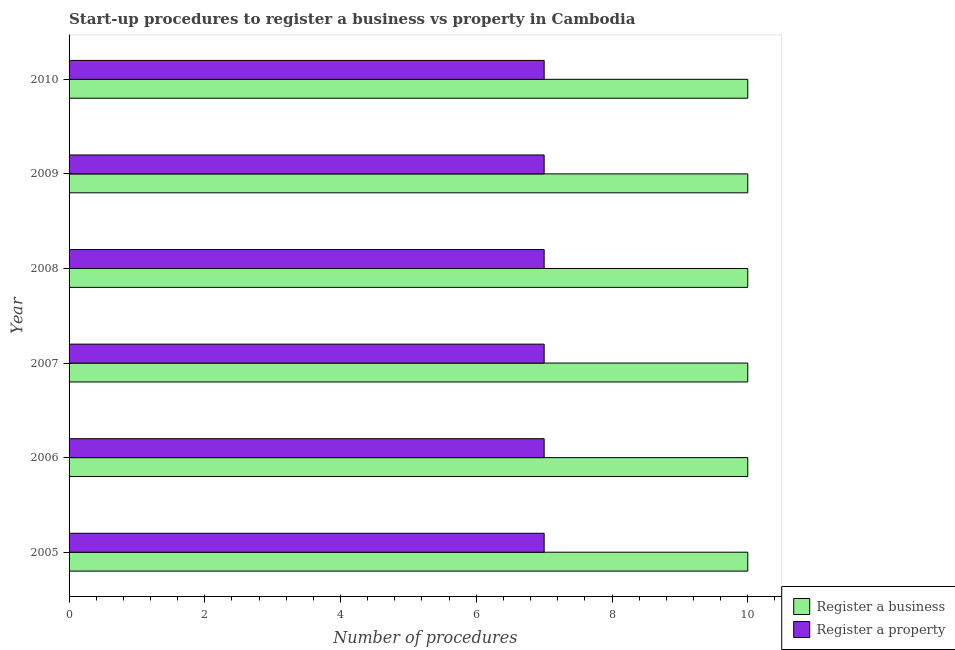How many different coloured bars are there?
Give a very brief answer. 2. How many groups of bars are there?
Offer a terse response. 6. How many bars are there on the 5th tick from the top?
Ensure brevity in your answer.  2. In how many cases, is the number of bars for a given year not equal to the number of legend labels?
Provide a succinct answer. 0. What is the number of procedures to register a property in 2009?
Make the answer very short. 7. Across all years, what is the maximum number of procedures to register a business?
Keep it short and to the point. 10. Across all years, what is the minimum number of procedures to register a business?
Offer a terse response. 10. In which year was the number of procedures to register a business minimum?
Offer a very short reply. 2005. What is the total number of procedures to register a property in the graph?
Offer a very short reply. 42. What is the difference between the number of procedures to register a property in 2007 and the number of procedures to register a business in 2006?
Make the answer very short. -3. What is the average number of procedures to register a business per year?
Your response must be concise. 10. In the year 2005, what is the difference between the number of procedures to register a property and number of procedures to register a business?
Make the answer very short. -3. In how many years, is the number of procedures to register a business greater than 4.8 ?
Your answer should be very brief. 6. What is the ratio of the number of procedures to register a business in 2007 to that in 2010?
Keep it short and to the point. 1. Is the difference between the number of procedures to register a business in 2007 and 2008 greater than the difference between the number of procedures to register a property in 2007 and 2008?
Offer a very short reply. No. What is the difference between the highest and the second highest number of procedures to register a business?
Ensure brevity in your answer.  0. What does the 2nd bar from the top in 2005 represents?
Your answer should be compact. Register a business. What does the 2nd bar from the bottom in 2005 represents?
Offer a very short reply. Register a property. How many bars are there?
Provide a succinct answer. 12. What is the difference between two consecutive major ticks on the X-axis?
Make the answer very short. 2. Are the values on the major ticks of X-axis written in scientific E-notation?
Your answer should be compact. No. Does the graph contain any zero values?
Your answer should be very brief. No. Does the graph contain grids?
Your answer should be very brief. No. Where does the legend appear in the graph?
Keep it short and to the point. Bottom right. What is the title of the graph?
Give a very brief answer. Start-up procedures to register a business vs property in Cambodia. What is the label or title of the X-axis?
Ensure brevity in your answer.  Number of procedures. What is the Number of procedures in Register a business in 2005?
Ensure brevity in your answer.  10. What is the Number of procedures in Register a property in 2005?
Make the answer very short. 7. What is the Number of procedures of Register a business in 2006?
Provide a short and direct response. 10. What is the Number of procedures in Register a business in 2008?
Keep it short and to the point. 10. What is the Number of procedures in Register a business in 2009?
Offer a terse response. 10. What is the Number of procedures of Register a property in 2010?
Provide a short and direct response. 7. Across all years, what is the maximum Number of procedures of Register a property?
Your response must be concise. 7. What is the total Number of procedures in Register a property in the graph?
Keep it short and to the point. 42. What is the difference between the Number of procedures in Register a property in 2005 and that in 2008?
Make the answer very short. 0. What is the difference between the Number of procedures in Register a business in 2005 and that in 2009?
Offer a very short reply. 0. What is the difference between the Number of procedures of Register a business in 2005 and that in 2010?
Keep it short and to the point. 0. What is the difference between the Number of procedures in Register a business in 2006 and that in 2007?
Provide a short and direct response. 0. What is the difference between the Number of procedures in Register a property in 2006 and that in 2008?
Make the answer very short. 0. What is the difference between the Number of procedures of Register a property in 2006 and that in 2009?
Offer a terse response. 0. What is the difference between the Number of procedures in Register a business in 2006 and that in 2010?
Keep it short and to the point. 0. What is the difference between the Number of procedures of Register a property in 2006 and that in 2010?
Offer a terse response. 0. What is the difference between the Number of procedures in Register a business in 2007 and that in 2008?
Your response must be concise. 0. What is the difference between the Number of procedures of Register a business in 2007 and that in 2009?
Your response must be concise. 0. What is the difference between the Number of procedures in Register a property in 2007 and that in 2009?
Keep it short and to the point. 0. What is the difference between the Number of procedures in Register a property in 2007 and that in 2010?
Provide a succinct answer. 0. What is the difference between the Number of procedures of Register a business in 2008 and that in 2009?
Offer a very short reply. 0. What is the difference between the Number of procedures in Register a business in 2008 and that in 2010?
Keep it short and to the point. 0. What is the difference between the Number of procedures in Register a property in 2008 and that in 2010?
Offer a terse response. 0. What is the difference between the Number of procedures of Register a business in 2009 and that in 2010?
Keep it short and to the point. 0. What is the difference between the Number of procedures in Register a property in 2009 and that in 2010?
Your answer should be compact. 0. What is the difference between the Number of procedures in Register a business in 2005 and the Number of procedures in Register a property in 2010?
Your answer should be compact. 3. What is the difference between the Number of procedures in Register a business in 2006 and the Number of procedures in Register a property in 2007?
Your answer should be compact. 3. What is the difference between the Number of procedures in Register a business in 2006 and the Number of procedures in Register a property in 2009?
Provide a short and direct response. 3. What is the difference between the Number of procedures of Register a business in 2007 and the Number of procedures of Register a property in 2009?
Your answer should be very brief. 3. What is the difference between the Number of procedures in Register a business in 2007 and the Number of procedures in Register a property in 2010?
Ensure brevity in your answer.  3. What is the difference between the Number of procedures in Register a business in 2009 and the Number of procedures in Register a property in 2010?
Keep it short and to the point. 3. In the year 2007, what is the difference between the Number of procedures of Register a business and Number of procedures of Register a property?
Make the answer very short. 3. In the year 2008, what is the difference between the Number of procedures in Register a business and Number of procedures in Register a property?
Your answer should be compact. 3. In the year 2009, what is the difference between the Number of procedures of Register a business and Number of procedures of Register a property?
Make the answer very short. 3. What is the ratio of the Number of procedures of Register a business in 2005 to that in 2006?
Keep it short and to the point. 1. What is the ratio of the Number of procedures of Register a business in 2005 to that in 2007?
Keep it short and to the point. 1. What is the ratio of the Number of procedures of Register a property in 2005 to that in 2007?
Ensure brevity in your answer.  1. What is the ratio of the Number of procedures in Register a property in 2005 to that in 2008?
Give a very brief answer. 1. What is the ratio of the Number of procedures in Register a business in 2005 to that in 2009?
Your response must be concise. 1. What is the ratio of the Number of procedures in Register a property in 2005 to that in 2009?
Your response must be concise. 1. What is the ratio of the Number of procedures in Register a property in 2005 to that in 2010?
Your answer should be compact. 1. What is the ratio of the Number of procedures in Register a business in 2006 to that in 2007?
Offer a very short reply. 1. What is the ratio of the Number of procedures of Register a business in 2006 to that in 2008?
Ensure brevity in your answer.  1. What is the ratio of the Number of procedures in Register a property in 2006 to that in 2009?
Your answer should be very brief. 1. What is the ratio of the Number of procedures of Register a business in 2006 to that in 2010?
Make the answer very short. 1. What is the ratio of the Number of procedures of Register a business in 2007 to that in 2008?
Provide a succinct answer. 1. What is the ratio of the Number of procedures of Register a business in 2007 to that in 2009?
Your answer should be compact. 1. What is the ratio of the Number of procedures of Register a property in 2007 to that in 2009?
Provide a succinct answer. 1. What is the ratio of the Number of procedures in Register a business in 2007 to that in 2010?
Provide a short and direct response. 1. What is the ratio of the Number of procedures of Register a business in 2008 to that in 2009?
Ensure brevity in your answer.  1. What is the ratio of the Number of procedures in Register a property in 2008 to that in 2009?
Ensure brevity in your answer.  1. What is the ratio of the Number of procedures of Register a property in 2008 to that in 2010?
Make the answer very short. 1. What is the ratio of the Number of procedures in Register a business in 2009 to that in 2010?
Keep it short and to the point. 1. What is the ratio of the Number of procedures in Register a property in 2009 to that in 2010?
Your answer should be compact. 1. What is the difference between the highest and the second highest Number of procedures of Register a property?
Keep it short and to the point. 0. What is the difference between the highest and the lowest Number of procedures in Register a property?
Make the answer very short. 0. 